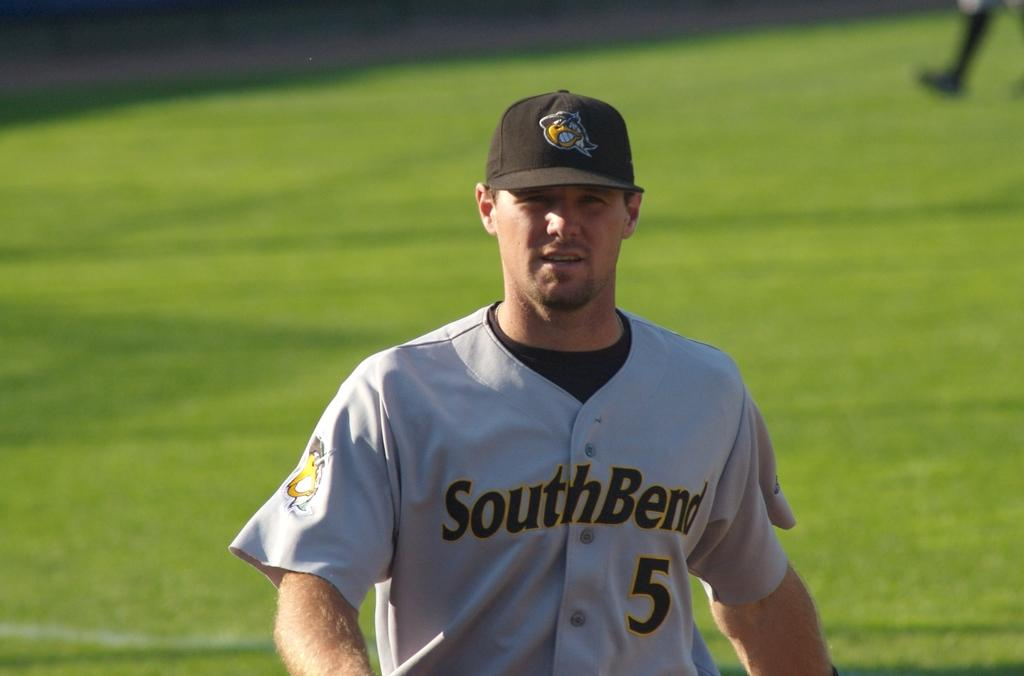Provide a one-sentence caption for the provided image. Baseball player with a South Bend uniform and ball cap on. 